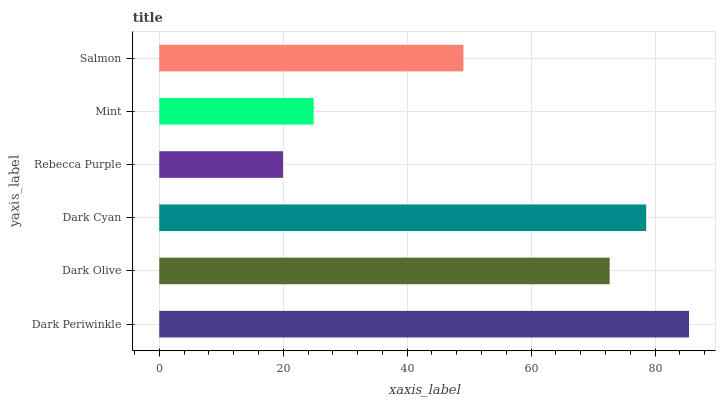Is Rebecca Purple the minimum?
Answer yes or no. Yes. Is Dark Periwinkle the maximum?
Answer yes or no. Yes. Is Dark Olive the minimum?
Answer yes or no. No. Is Dark Olive the maximum?
Answer yes or no. No. Is Dark Periwinkle greater than Dark Olive?
Answer yes or no. Yes. Is Dark Olive less than Dark Periwinkle?
Answer yes or no. Yes. Is Dark Olive greater than Dark Periwinkle?
Answer yes or no. No. Is Dark Periwinkle less than Dark Olive?
Answer yes or no. No. Is Dark Olive the high median?
Answer yes or no. Yes. Is Salmon the low median?
Answer yes or no. Yes. Is Dark Periwinkle the high median?
Answer yes or no. No. Is Dark Olive the low median?
Answer yes or no. No. 